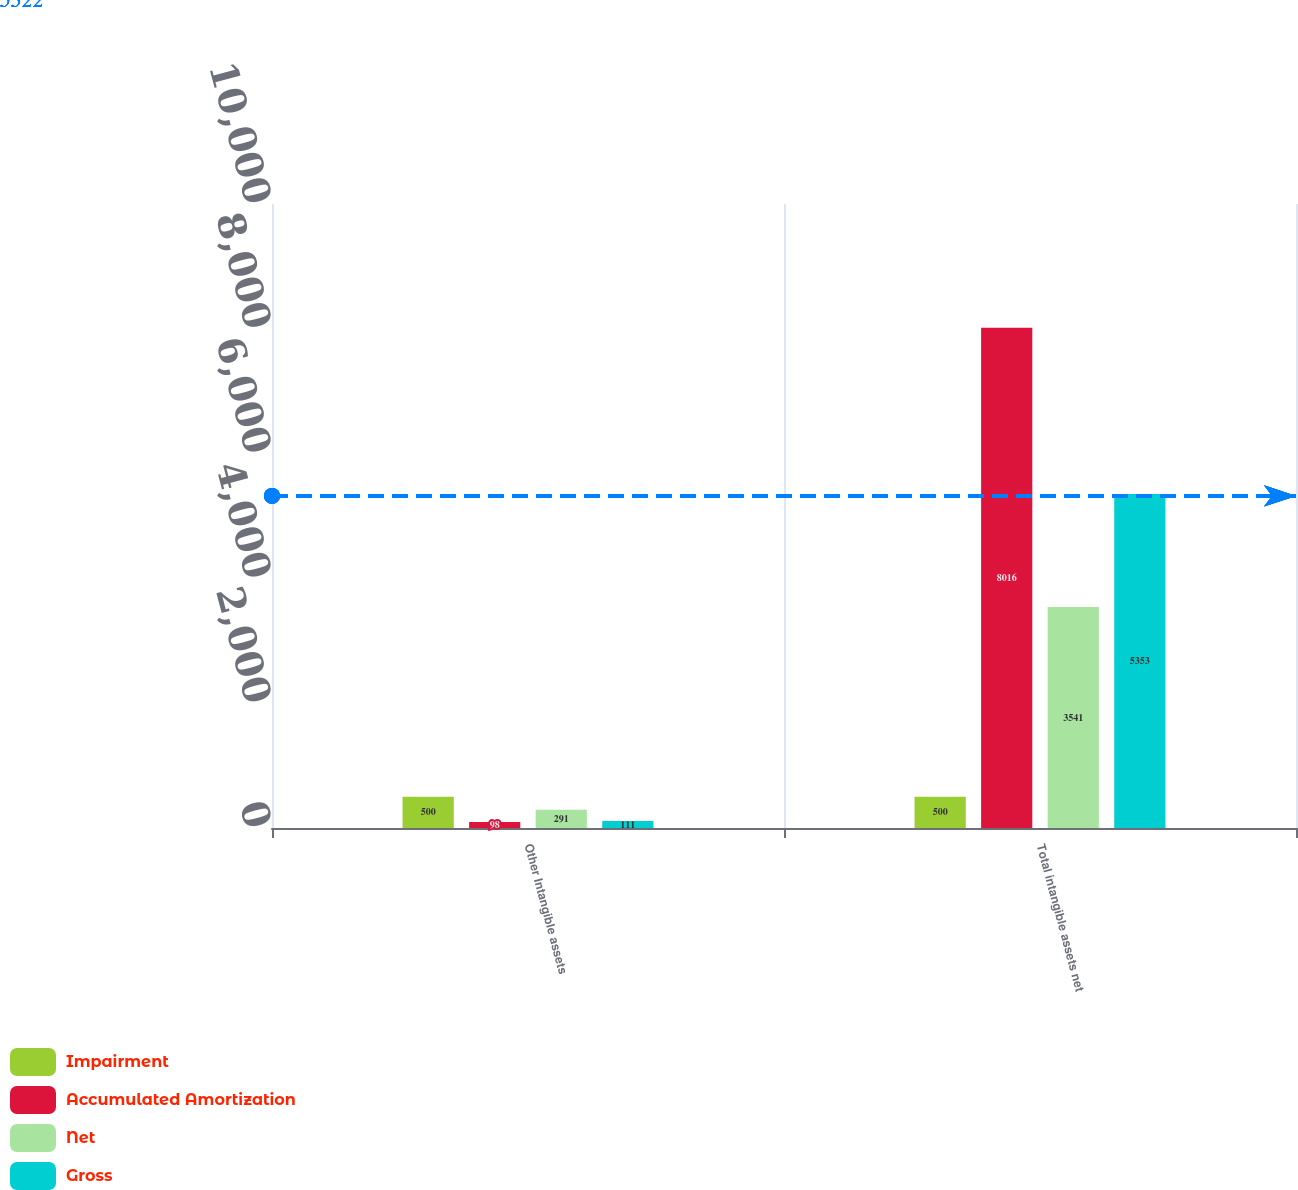Convert chart. <chart><loc_0><loc_0><loc_500><loc_500><stacked_bar_chart><ecel><fcel>Other Intangible assets<fcel>Total intangible assets net<nl><fcel>Impairment<fcel>500<fcel>500<nl><fcel>Accumulated Amortization<fcel>98<fcel>8016<nl><fcel>Net<fcel>291<fcel>3541<nl><fcel>Gross<fcel>111<fcel>5353<nl></chart> 